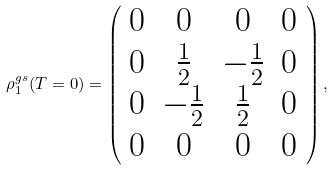Convert formula to latex. <formula><loc_0><loc_0><loc_500><loc_500>\rho _ { 1 } ^ { g s } ( T = 0 ) = \left ( \begin{array} { c c c c } 0 & 0 & 0 & 0 \\ 0 & \frac { 1 } { 2 } & - \frac { 1 } { 2 } & 0 \\ 0 & - \frac { 1 } { 2 } & \frac { 1 } { 2 } & 0 \\ 0 & 0 & 0 & 0 \end{array} \right ) ,</formula> 